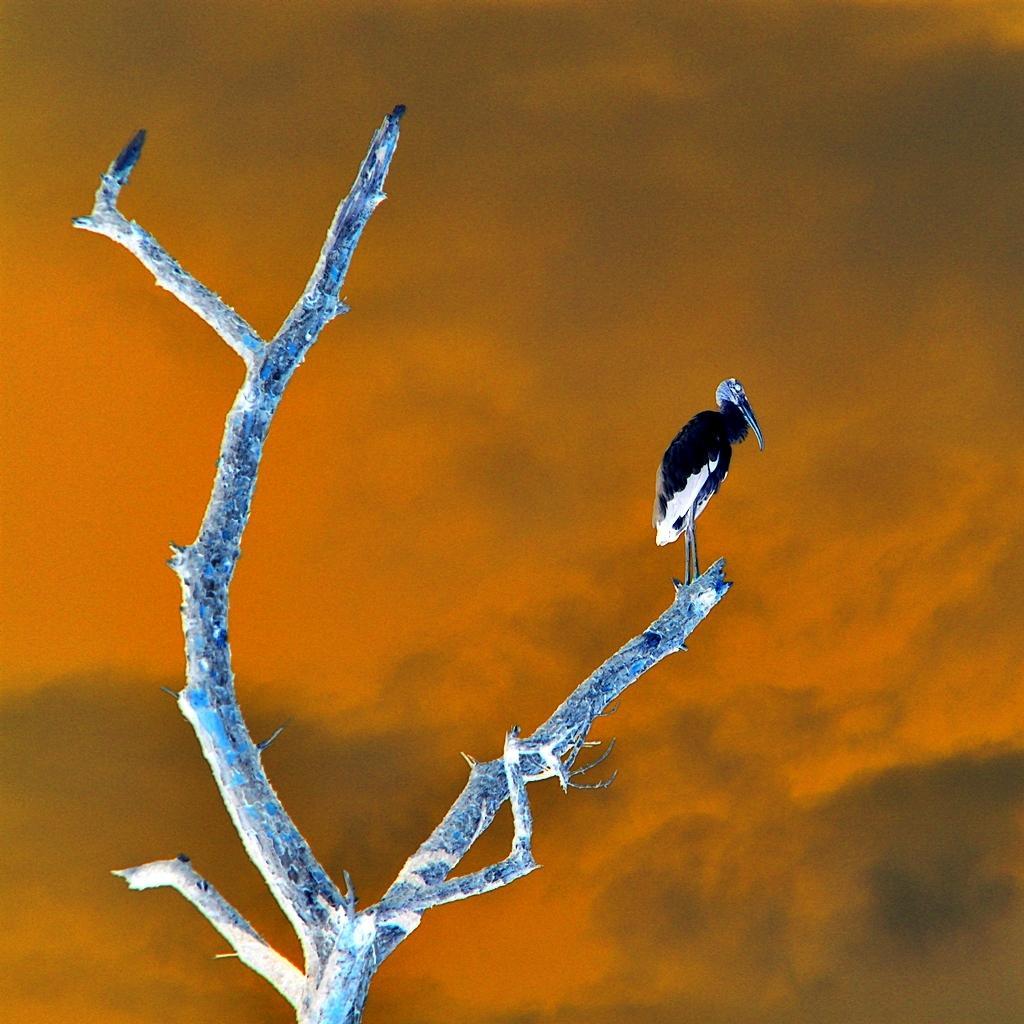Can you describe this image briefly? In this image, we can see a bird on a branch, we can see the sky. 